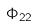<formula> <loc_0><loc_0><loc_500><loc_500>\Phi _ { 2 2 }</formula> 